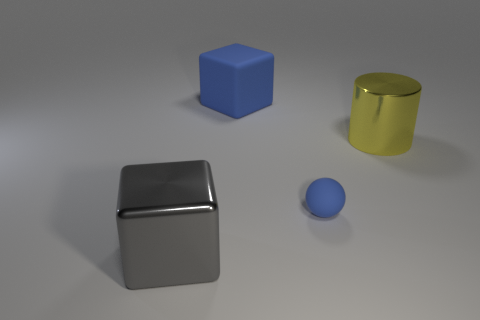Add 4 metal things. How many objects exist? 8 Subtract all spheres. How many objects are left? 3 Subtract all yellow metallic spheres. Subtract all metal cylinders. How many objects are left? 3 Add 3 rubber blocks. How many rubber blocks are left? 4 Add 1 large purple matte blocks. How many large purple matte blocks exist? 1 Subtract 0 gray cylinders. How many objects are left? 4 